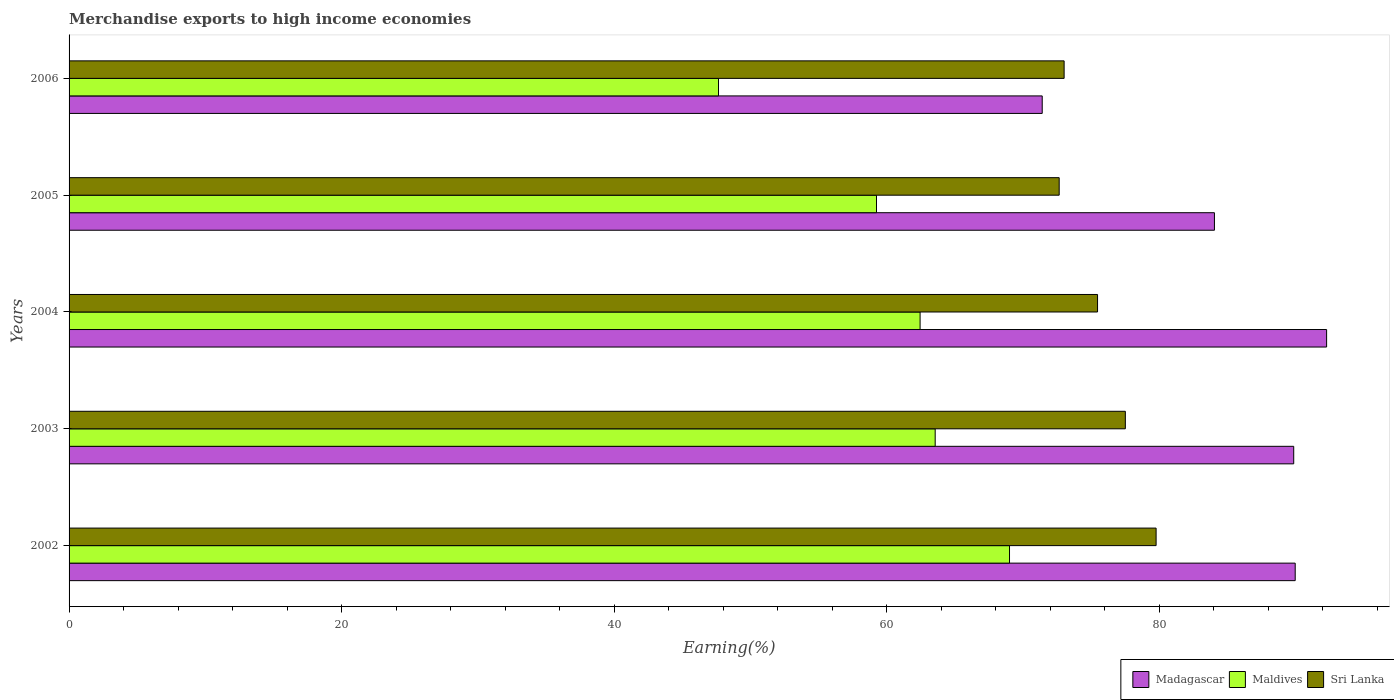How many bars are there on the 3rd tick from the top?
Offer a terse response. 3. What is the percentage of amount earned from merchandise exports in Maldives in 2004?
Your response must be concise. 62.44. Across all years, what is the maximum percentage of amount earned from merchandise exports in Maldives?
Provide a succinct answer. 69.01. Across all years, what is the minimum percentage of amount earned from merchandise exports in Madagascar?
Make the answer very short. 71.4. In which year was the percentage of amount earned from merchandise exports in Madagascar maximum?
Provide a short and direct response. 2004. What is the total percentage of amount earned from merchandise exports in Maldives in the graph?
Provide a succinct answer. 301.9. What is the difference between the percentage of amount earned from merchandise exports in Maldives in 2002 and that in 2003?
Your answer should be very brief. 5.45. What is the difference between the percentage of amount earned from merchandise exports in Madagascar in 2004 and the percentage of amount earned from merchandise exports in Sri Lanka in 2002?
Make the answer very short. 12.51. What is the average percentage of amount earned from merchandise exports in Maldives per year?
Make the answer very short. 60.38. In the year 2003, what is the difference between the percentage of amount earned from merchandise exports in Sri Lanka and percentage of amount earned from merchandise exports in Madagascar?
Your response must be concise. -12.35. What is the ratio of the percentage of amount earned from merchandise exports in Madagascar in 2002 to that in 2005?
Make the answer very short. 1.07. Is the percentage of amount earned from merchandise exports in Sri Lanka in 2003 less than that in 2004?
Your answer should be compact. No. Is the difference between the percentage of amount earned from merchandise exports in Sri Lanka in 2003 and 2006 greater than the difference between the percentage of amount earned from merchandise exports in Madagascar in 2003 and 2006?
Provide a short and direct response. No. What is the difference between the highest and the second highest percentage of amount earned from merchandise exports in Sri Lanka?
Give a very brief answer. 2.26. What is the difference between the highest and the lowest percentage of amount earned from merchandise exports in Maldives?
Offer a terse response. 21.35. What does the 2nd bar from the top in 2004 represents?
Keep it short and to the point. Maldives. What does the 2nd bar from the bottom in 2005 represents?
Provide a succinct answer. Maldives. Is it the case that in every year, the sum of the percentage of amount earned from merchandise exports in Sri Lanka and percentage of amount earned from merchandise exports in Maldives is greater than the percentage of amount earned from merchandise exports in Madagascar?
Provide a short and direct response. Yes. Are all the bars in the graph horizontal?
Offer a terse response. Yes. How many years are there in the graph?
Offer a terse response. 5. What is the difference between two consecutive major ticks on the X-axis?
Your answer should be very brief. 20. Does the graph contain any zero values?
Provide a succinct answer. No. Does the graph contain grids?
Your answer should be compact. No. Where does the legend appear in the graph?
Your answer should be compact. Bottom right. How are the legend labels stacked?
Give a very brief answer. Horizontal. What is the title of the graph?
Offer a terse response. Merchandise exports to high income economies. Does "Monaco" appear as one of the legend labels in the graph?
Provide a succinct answer. No. What is the label or title of the X-axis?
Your response must be concise. Earning(%). What is the label or title of the Y-axis?
Offer a very short reply. Years. What is the Earning(%) of Madagascar in 2002?
Make the answer very short. 89.97. What is the Earning(%) in Maldives in 2002?
Keep it short and to the point. 69.01. What is the Earning(%) in Sri Lanka in 2002?
Your answer should be very brief. 79.76. What is the Earning(%) in Madagascar in 2003?
Offer a very short reply. 89.86. What is the Earning(%) in Maldives in 2003?
Give a very brief answer. 63.55. What is the Earning(%) of Sri Lanka in 2003?
Make the answer very short. 77.5. What is the Earning(%) of Madagascar in 2004?
Provide a short and direct response. 92.27. What is the Earning(%) in Maldives in 2004?
Make the answer very short. 62.44. What is the Earning(%) of Sri Lanka in 2004?
Make the answer very short. 75.46. What is the Earning(%) of Madagascar in 2005?
Your answer should be compact. 84.04. What is the Earning(%) in Maldives in 2005?
Provide a succinct answer. 59.24. What is the Earning(%) of Sri Lanka in 2005?
Keep it short and to the point. 72.65. What is the Earning(%) in Madagascar in 2006?
Your answer should be very brief. 71.4. What is the Earning(%) in Maldives in 2006?
Provide a succinct answer. 47.65. What is the Earning(%) of Sri Lanka in 2006?
Your response must be concise. 73.01. Across all years, what is the maximum Earning(%) in Madagascar?
Your answer should be compact. 92.27. Across all years, what is the maximum Earning(%) of Maldives?
Your response must be concise. 69.01. Across all years, what is the maximum Earning(%) of Sri Lanka?
Give a very brief answer. 79.76. Across all years, what is the minimum Earning(%) of Madagascar?
Provide a succinct answer. 71.4. Across all years, what is the minimum Earning(%) in Maldives?
Your response must be concise. 47.65. Across all years, what is the minimum Earning(%) of Sri Lanka?
Your response must be concise. 72.65. What is the total Earning(%) in Madagascar in the graph?
Your answer should be compact. 427.54. What is the total Earning(%) of Maldives in the graph?
Provide a succinct answer. 301.9. What is the total Earning(%) of Sri Lanka in the graph?
Offer a terse response. 378.39. What is the difference between the Earning(%) of Madagascar in 2002 and that in 2003?
Your response must be concise. 0.11. What is the difference between the Earning(%) in Maldives in 2002 and that in 2003?
Provide a short and direct response. 5.45. What is the difference between the Earning(%) of Sri Lanka in 2002 and that in 2003?
Your answer should be very brief. 2.26. What is the difference between the Earning(%) in Madagascar in 2002 and that in 2004?
Offer a terse response. -2.3. What is the difference between the Earning(%) in Maldives in 2002 and that in 2004?
Provide a short and direct response. 6.56. What is the difference between the Earning(%) of Sri Lanka in 2002 and that in 2004?
Offer a very short reply. 4.3. What is the difference between the Earning(%) in Madagascar in 2002 and that in 2005?
Your response must be concise. 5.93. What is the difference between the Earning(%) of Maldives in 2002 and that in 2005?
Your response must be concise. 9.76. What is the difference between the Earning(%) of Sri Lanka in 2002 and that in 2005?
Ensure brevity in your answer.  7.11. What is the difference between the Earning(%) of Madagascar in 2002 and that in 2006?
Give a very brief answer. 18.56. What is the difference between the Earning(%) in Maldives in 2002 and that in 2006?
Your answer should be compact. 21.35. What is the difference between the Earning(%) of Sri Lanka in 2002 and that in 2006?
Provide a succinct answer. 6.75. What is the difference between the Earning(%) of Madagascar in 2003 and that in 2004?
Ensure brevity in your answer.  -2.41. What is the difference between the Earning(%) in Maldives in 2003 and that in 2004?
Provide a short and direct response. 1.11. What is the difference between the Earning(%) of Sri Lanka in 2003 and that in 2004?
Your response must be concise. 2.04. What is the difference between the Earning(%) of Madagascar in 2003 and that in 2005?
Provide a succinct answer. 5.82. What is the difference between the Earning(%) of Maldives in 2003 and that in 2005?
Your answer should be compact. 4.31. What is the difference between the Earning(%) of Sri Lanka in 2003 and that in 2005?
Keep it short and to the point. 4.85. What is the difference between the Earning(%) in Madagascar in 2003 and that in 2006?
Keep it short and to the point. 18.45. What is the difference between the Earning(%) of Maldives in 2003 and that in 2006?
Offer a very short reply. 15.9. What is the difference between the Earning(%) in Sri Lanka in 2003 and that in 2006?
Provide a succinct answer. 4.49. What is the difference between the Earning(%) in Madagascar in 2004 and that in 2005?
Offer a terse response. 8.23. What is the difference between the Earning(%) of Maldives in 2004 and that in 2005?
Your answer should be very brief. 3.2. What is the difference between the Earning(%) in Sri Lanka in 2004 and that in 2005?
Offer a very short reply. 2.82. What is the difference between the Earning(%) in Madagascar in 2004 and that in 2006?
Offer a terse response. 20.87. What is the difference between the Earning(%) of Maldives in 2004 and that in 2006?
Your answer should be compact. 14.79. What is the difference between the Earning(%) in Sri Lanka in 2004 and that in 2006?
Your answer should be very brief. 2.45. What is the difference between the Earning(%) in Madagascar in 2005 and that in 2006?
Ensure brevity in your answer.  12.64. What is the difference between the Earning(%) of Maldives in 2005 and that in 2006?
Give a very brief answer. 11.59. What is the difference between the Earning(%) in Sri Lanka in 2005 and that in 2006?
Offer a terse response. -0.36. What is the difference between the Earning(%) of Madagascar in 2002 and the Earning(%) of Maldives in 2003?
Provide a succinct answer. 26.42. What is the difference between the Earning(%) of Madagascar in 2002 and the Earning(%) of Sri Lanka in 2003?
Make the answer very short. 12.46. What is the difference between the Earning(%) of Maldives in 2002 and the Earning(%) of Sri Lanka in 2003?
Offer a terse response. -8.5. What is the difference between the Earning(%) in Madagascar in 2002 and the Earning(%) in Maldives in 2004?
Ensure brevity in your answer.  27.52. What is the difference between the Earning(%) in Madagascar in 2002 and the Earning(%) in Sri Lanka in 2004?
Your answer should be compact. 14.5. What is the difference between the Earning(%) in Maldives in 2002 and the Earning(%) in Sri Lanka in 2004?
Ensure brevity in your answer.  -6.46. What is the difference between the Earning(%) in Madagascar in 2002 and the Earning(%) in Maldives in 2005?
Ensure brevity in your answer.  30.72. What is the difference between the Earning(%) of Madagascar in 2002 and the Earning(%) of Sri Lanka in 2005?
Provide a succinct answer. 17.32. What is the difference between the Earning(%) in Maldives in 2002 and the Earning(%) in Sri Lanka in 2005?
Offer a terse response. -3.64. What is the difference between the Earning(%) of Madagascar in 2002 and the Earning(%) of Maldives in 2006?
Offer a very short reply. 42.31. What is the difference between the Earning(%) of Madagascar in 2002 and the Earning(%) of Sri Lanka in 2006?
Offer a very short reply. 16.96. What is the difference between the Earning(%) in Maldives in 2002 and the Earning(%) in Sri Lanka in 2006?
Offer a terse response. -4.01. What is the difference between the Earning(%) in Madagascar in 2003 and the Earning(%) in Maldives in 2004?
Offer a terse response. 27.41. What is the difference between the Earning(%) of Madagascar in 2003 and the Earning(%) of Sri Lanka in 2004?
Keep it short and to the point. 14.39. What is the difference between the Earning(%) in Maldives in 2003 and the Earning(%) in Sri Lanka in 2004?
Your response must be concise. -11.91. What is the difference between the Earning(%) in Madagascar in 2003 and the Earning(%) in Maldives in 2005?
Offer a very short reply. 30.61. What is the difference between the Earning(%) in Madagascar in 2003 and the Earning(%) in Sri Lanka in 2005?
Your response must be concise. 17.21. What is the difference between the Earning(%) in Maldives in 2003 and the Earning(%) in Sri Lanka in 2005?
Your answer should be compact. -9.1. What is the difference between the Earning(%) of Madagascar in 2003 and the Earning(%) of Maldives in 2006?
Ensure brevity in your answer.  42.2. What is the difference between the Earning(%) in Madagascar in 2003 and the Earning(%) in Sri Lanka in 2006?
Your response must be concise. 16.85. What is the difference between the Earning(%) of Maldives in 2003 and the Earning(%) of Sri Lanka in 2006?
Keep it short and to the point. -9.46. What is the difference between the Earning(%) in Madagascar in 2004 and the Earning(%) in Maldives in 2005?
Provide a succinct answer. 33.03. What is the difference between the Earning(%) in Madagascar in 2004 and the Earning(%) in Sri Lanka in 2005?
Provide a short and direct response. 19.62. What is the difference between the Earning(%) of Maldives in 2004 and the Earning(%) of Sri Lanka in 2005?
Provide a short and direct response. -10.21. What is the difference between the Earning(%) of Madagascar in 2004 and the Earning(%) of Maldives in 2006?
Your response must be concise. 44.62. What is the difference between the Earning(%) of Madagascar in 2004 and the Earning(%) of Sri Lanka in 2006?
Your answer should be very brief. 19.26. What is the difference between the Earning(%) in Maldives in 2004 and the Earning(%) in Sri Lanka in 2006?
Your answer should be very brief. -10.57. What is the difference between the Earning(%) of Madagascar in 2005 and the Earning(%) of Maldives in 2006?
Your answer should be very brief. 36.39. What is the difference between the Earning(%) in Madagascar in 2005 and the Earning(%) in Sri Lanka in 2006?
Provide a succinct answer. 11.03. What is the difference between the Earning(%) in Maldives in 2005 and the Earning(%) in Sri Lanka in 2006?
Ensure brevity in your answer.  -13.77. What is the average Earning(%) of Madagascar per year?
Give a very brief answer. 85.51. What is the average Earning(%) of Maldives per year?
Make the answer very short. 60.38. What is the average Earning(%) of Sri Lanka per year?
Offer a very short reply. 75.68. In the year 2002, what is the difference between the Earning(%) in Madagascar and Earning(%) in Maldives?
Make the answer very short. 20.96. In the year 2002, what is the difference between the Earning(%) of Madagascar and Earning(%) of Sri Lanka?
Ensure brevity in your answer.  10.21. In the year 2002, what is the difference between the Earning(%) in Maldives and Earning(%) in Sri Lanka?
Offer a terse response. -10.76. In the year 2003, what is the difference between the Earning(%) in Madagascar and Earning(%) in Maldives?
Offer a very short reply. 26.31. In the year 2003, what is the difference between the Earning(%) in Madagascar and Earning(%) in Sri Lanka?
Offer a terse response. 12.35. In the year 2003, what is the difference between the Earning(%) in Maldives and Earning(%) in Sri Lanka?
Your response must be concise. -13.95. In the year 2004, what is the difference between the Earning(%) of Madagascar and Earning(%) of Maldives?
Your answer should be very brief. 29.83. In the year 2004, what is the difference between the Earning(%) in Madagascar and Earning(%) in Sri Lanka?
Offer a very short reply. 16.81. In the year 2004, what is the difference between the Earning(%) in Maldives and Earning(%) in Sri Lanka?
Offer a terse response. -13.02. In the year 2005, what is the difference between the Earning(%) of Madagascar and Earning(%) of Maldives?
Make the answer very short. 24.8. In the year 2005, what is the difference between the Earning(%) of Madagascar and Earning(%) of Sri Lanka?
Ensure brevity in your answer.  11.39. In the year 2005, what is the difference between the Earning(%) of Maldives and Earning(%) of Sri Lanka?
Your answer should be compact. -13.4. In the year 2006, what is the difference between the Earning(%) of Madagascar and Earning(%) of Maldives?
Your response must be concise. 23.75. In the year 2006, what is the difference between the Earning(%) of Madagascar and Earning(%) of Sri Lanka?
Your answer should be very brief. -1.61. In the year 2006, what is the difference between the Earning(%) of Maldives and Earning(%) of Sri Lanka?
Give a very brief answer. -25.36. What is the ratio of the Earning(%) in Maldives in 2002 to that in 2003?
Provide a short and direct response. 1.09. What is the ratio of the Earning(%) in Sri Lanka in 2002 to that in 2003?
Keep it short and to the point. 1.03. What is the ratio of the Earning(%) in Maldives in 2002 to that in 2004?
Keep it short and to the point. 1.11. What is the ratio of the Earning(%) of Sri Lanka in 2002 to that in 2004?
Your response must be concise. 1.06. What is the ratio of the Earning(%) of Madagascar in 2002 to that in 2005?
Ensure brevity in your answer.  1.07. What is the ratio of the Earning(%) of Maldives in 2002 to that in 2005?
Make the answer very short. 1.16. What is the ratio of the Earning(%) in Sri Lanka in 2002 to that in 2005?
Your response must be concise. 1.1. What is the ratio of the Earning(%) in Madagascar in 2002 to that in 2006?
Ensure brevity in your answer.  1.26. What is the ratio of the Earning(%) of Maldives in 2002 to that in 2006?
Make the answer very short. 1.45. What is the ratio of the Earning(%) in Sri Lanka in 2002 to that in 2006?
Make the answer very short. 1.09. What is the ratio of the Earning(%) of Madagascar in 2003 to that in 2004?
Your answer should be compact. 0.97. What is the ratio of the Earning(%) in Maldives in 2003 to that in 2004?
Make the answer very short. 1.02. What is the ratio of the Earning(%) in Madagascar in 2003 to that in 2005?
Your answer should be compact. 1.07. What is the ratio of the Earning(%) in Maldives in 2003 to that in 2005?
Your response must be concise. 1.07. What is the ratio of the Earning(%) in Sri Lanka in 2003 to that in 2005?
Keep it short and to the point. 1.07. What is the ratio of the Earning(%) in Madagascar in 2003 to that in 2006?
Ensure brevity in your answer.  1.26. What is the ratio of the Earning(%) in Maldives in 2003 to that in 2006?
Make the answer very short. 1.33. What is the ratio of the Earning(%) in Sri Lanka in 2003 to that in 2006?
Ensure brevity in your answer.  1.06. What is the ratio of the Earning(%) in Madagascar in 2004 to that in 2005?
Give a very brief answer. 1.1. What is the ratio of the Earning(%) in Maldives in 2004 to that in 2005?
Offer a terse response. 1.05. What is the ratio of the Earning(%) in Sri Lanka in 2004 to that in 2005?
Your answer should be very brief. 1.04. What is the ratio of the Earning(%) in Madagascar in 2004 to that in 2006?
Keep it short and to the point. 1.29. What is the ratio of the Earning(%) in Maldives in 2004 to that in 2006?
Your answer should be compact. 1.31. What is the ratio of the Earning(%) of Sri Lanka in 2004 to that in 2006?
Offer a terse response. 1.03. What is the ratio of the Earning(%) in Madagascar in 2005 to that in 2006?
Your response must be concise. 1.18. What is the ratio of the Earning(%) in Maldives in 2005 to that in 2006?
Your response must be concise. 1.24. What is the difference between the highest and the second highest Earning(%) of Madagascar?
Provide a short and direct response. 2.3. What is the difference between the highest and the second highest Earning(%) of Maldives?
Your response must be concise. 5.45. What is the difference between the highest and the second highest Earning(%) of Sri Lanka?
Offer a terse response. 2.26. What is the difference between the highest and the lowest Earning(%) in Madagascar?
Your answer should be very brief. 20.87. What is the difference between the highest and the lowest Earning(%) of Maldives?
Your answer should be very brief. 21.35. What is the difference between the highest and the lowest Earning(%) in Sri Lanka?
Give a very brief answer. 7.11. 